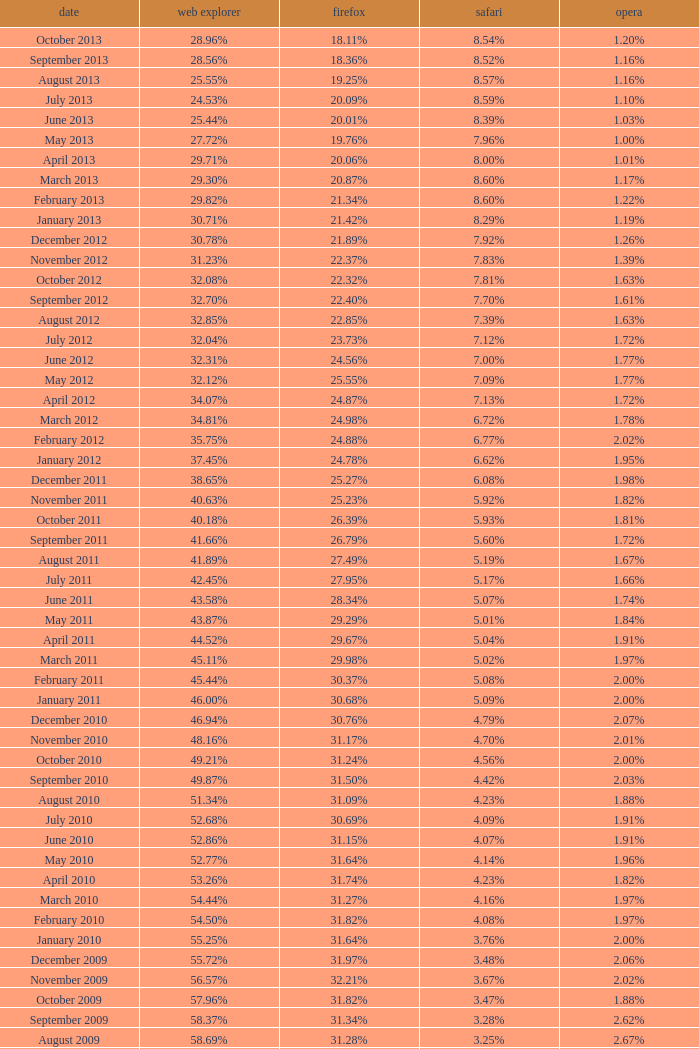What percentage of browsers were using Opera in October 2010? 2.00%. 